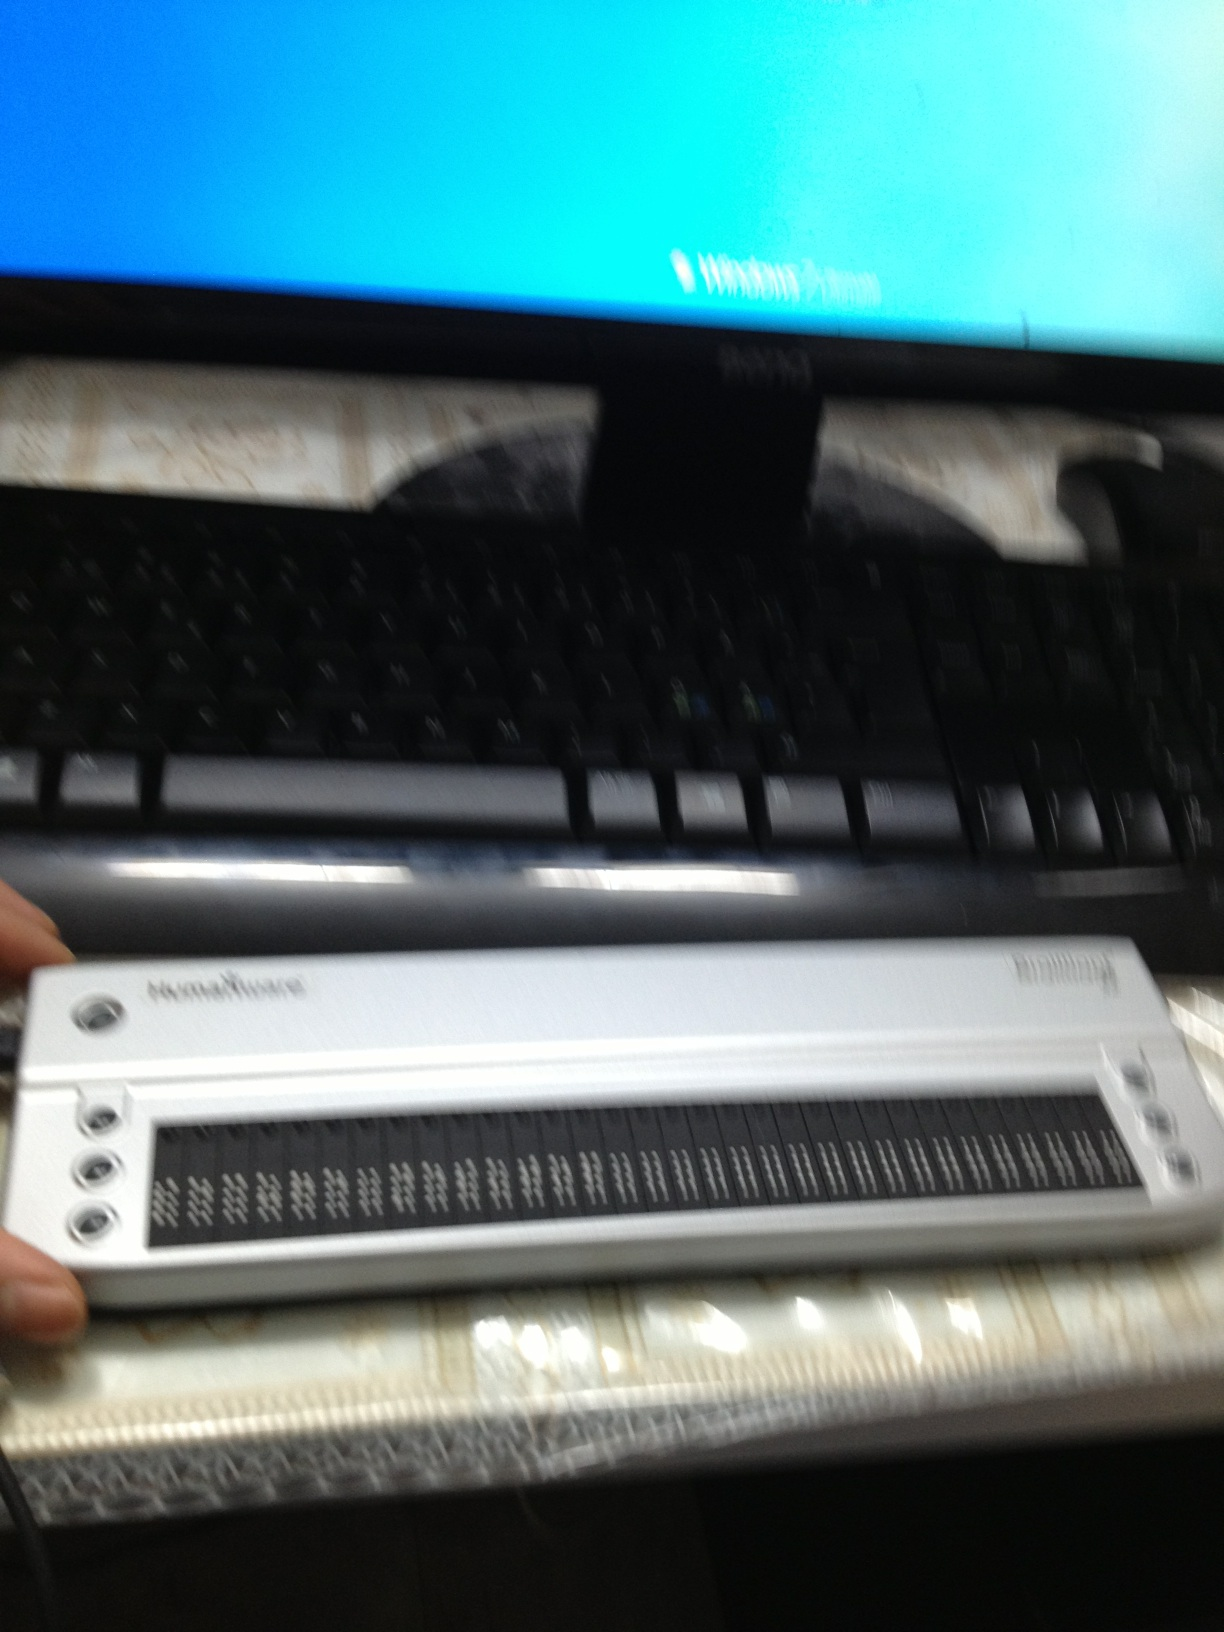What kind of device is shown in the image? The device shown in the image is a refreshable braille display. It is used to assist visually impaired individuals by converting digital text into braille. How does a refreshable braille display work? A refreshable braille display works by raising and lowering different combinations of pins through holes in a flat surface to create braille characters. These displays connect to computers or other digital devices and translate text into braille, enabling visually impaired users to read and interact with digital information. 